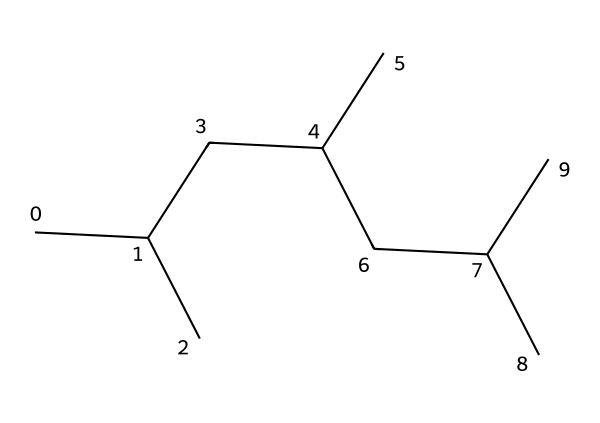What is the primary structural feature of polypropylene? The primary structural feature of polypropylene is its repeating unit of propylene, which is visible in the zigzag arrangement of carbon atoms in the SMILES representation.
Answer: repeating unit of propylene How many carbon atoms are present in this structure? By interpreting the SMILES notation, we count a total of 9 carbon atoms in the chemical structure. Each "C" represents a carbon atom, and when analyzing the structure, they sum up to 9.
Answer: 9 What type of bonds are found between the carbon atoms? The connections between carbon atoms in this structure are primarily single covalent bonds, as indicated by the absence of double or triple bonds in the SMILES representation.
Answer: single covalent bonds What is the degree of polymerization indicated here? The degree of polymerization can be inferred from the number of repeating propylene units in the polymer chain; based on the SMILES, it indicates a simple polymer of multiple propylene units, typically indicating a short polymer chain.
Answer: short polymer chain How does this structure affect the flexibility of polypropylene fibers? The long-chain hydrocarbons and the absence of significant branching allow for flexibility; the presence of straight-chain hydrocarbons contributes to its flexibility compared to more rigid structures.
Answer: flexibility What physical property does this molecular structure contribute to polypropylene fibers? The molecular structure contributes to a high tensile strength due to the strong covalent bonds between carbon atoms in the long chains of polypropylene fibers.
Answer: high tensile strength 